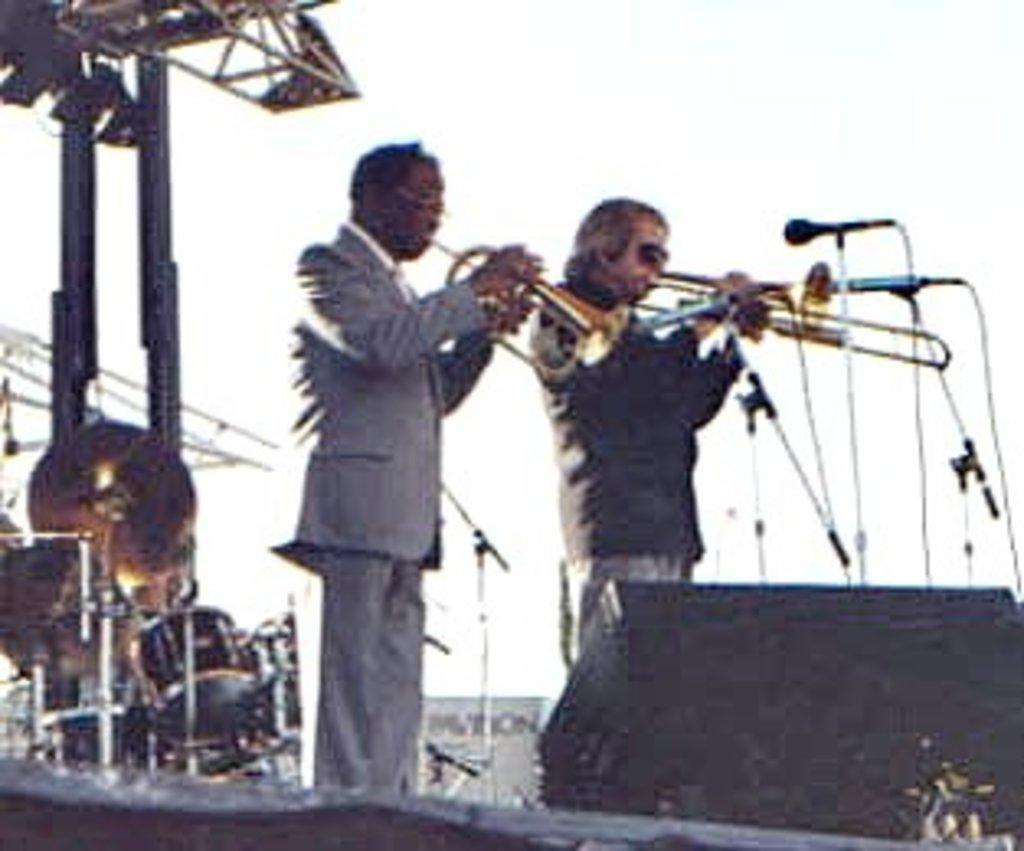Please provide a concise description of this image. In the image there are two men standing on the dais and playing a saxophone, in front of the men there are two mics and behind them there are some other music instruments like drums, in the background there is a sky. 